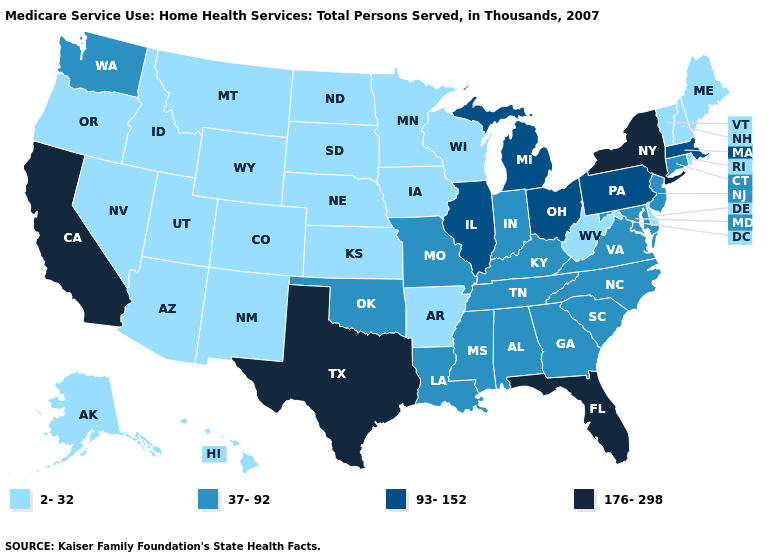What is the value of Kentucky?
Answer briefly. 37-92. What is the highest value in states that border Vermont?
Concise answer only. 176-298. Does South Carolina have a lower value than New York?
Short answer required. Yes. Name the states that have a value in the range 176-298?
Be succinct. California, Florida, New York, Texas. How many symbols are there in the legend?
Quick response, please. 4. Name the states that have a value in the range 2-32?
Keep it brief. Alaska, Arizona, Arkansas, Colorado, Delaware, Hawaii, Idaho, Iowa, Kansas, Maine, Minnesota, Montana, Nebraska, Nevada, New Hampshire, New Mexico, North Dakota, Oregon, Rhode Island, South Dakota, Utah, Vermont, West Virginia, Wisconsin, Wyoming. What is the value of West Virginia?
Answer briefly. 2-32. Name the states that have a value in the range 176-298?
Keep it brief. California, Florida, New York, Texas. Among the states that border Massachusetts , does Connecticut have the highest value?
Keep it brief. No. Does Alabama have a higher value than Idaho?
Short answer required. Yes. What is the value of Alaska?
Concise answer only. 2-32. How many symbols are there in the legend?
Write a very short answer. 4. Among the states that border Kentucky , does Illinois have the highest value?
Be succinct. Yes. Which states have the lowest value in the South?
Keep it brief. Arkansas, Delaware, West Virginia. 